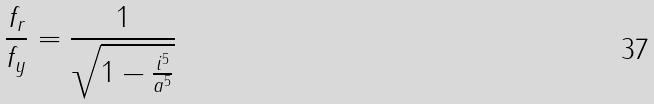<formula> <loc_0><loc_0><loc_500><loc_500>\frac { f _ { r } } { f _ { y } } = \frac { 1 } { \sqrt { 1 - \frac { i ^ { 5 } } { a ^ { 5 } } } }</formula> 